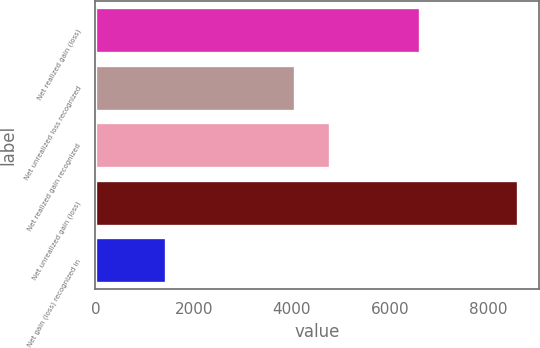<chart> <loc_0><loc_0><loc_500><loc_500><bar_chart><fcel>Net realized gain (loss)<fcel>Net unrealized loss recognized<fcel>Net realized gain recognized<fcel>Net unrealized gain (loss)<fcel>Net gain (loss) recognized in<nl><fcel>6604<fcel>4062<fcel>4779.5<fcel>8606<fcel>1431<nl></chart> 